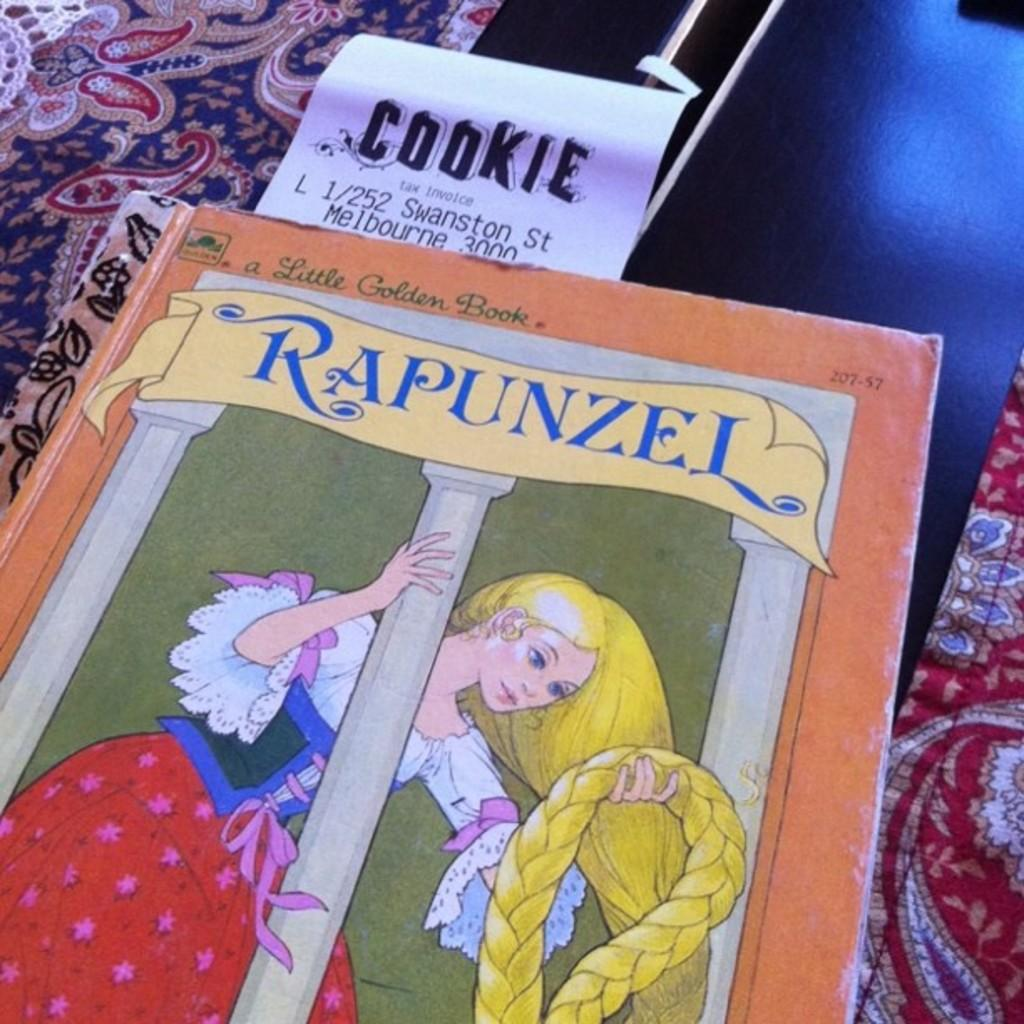<image>
Offer a succinct explanation of the picture presented. A Rapunzel book has a receipt in it from the store COOKIE 